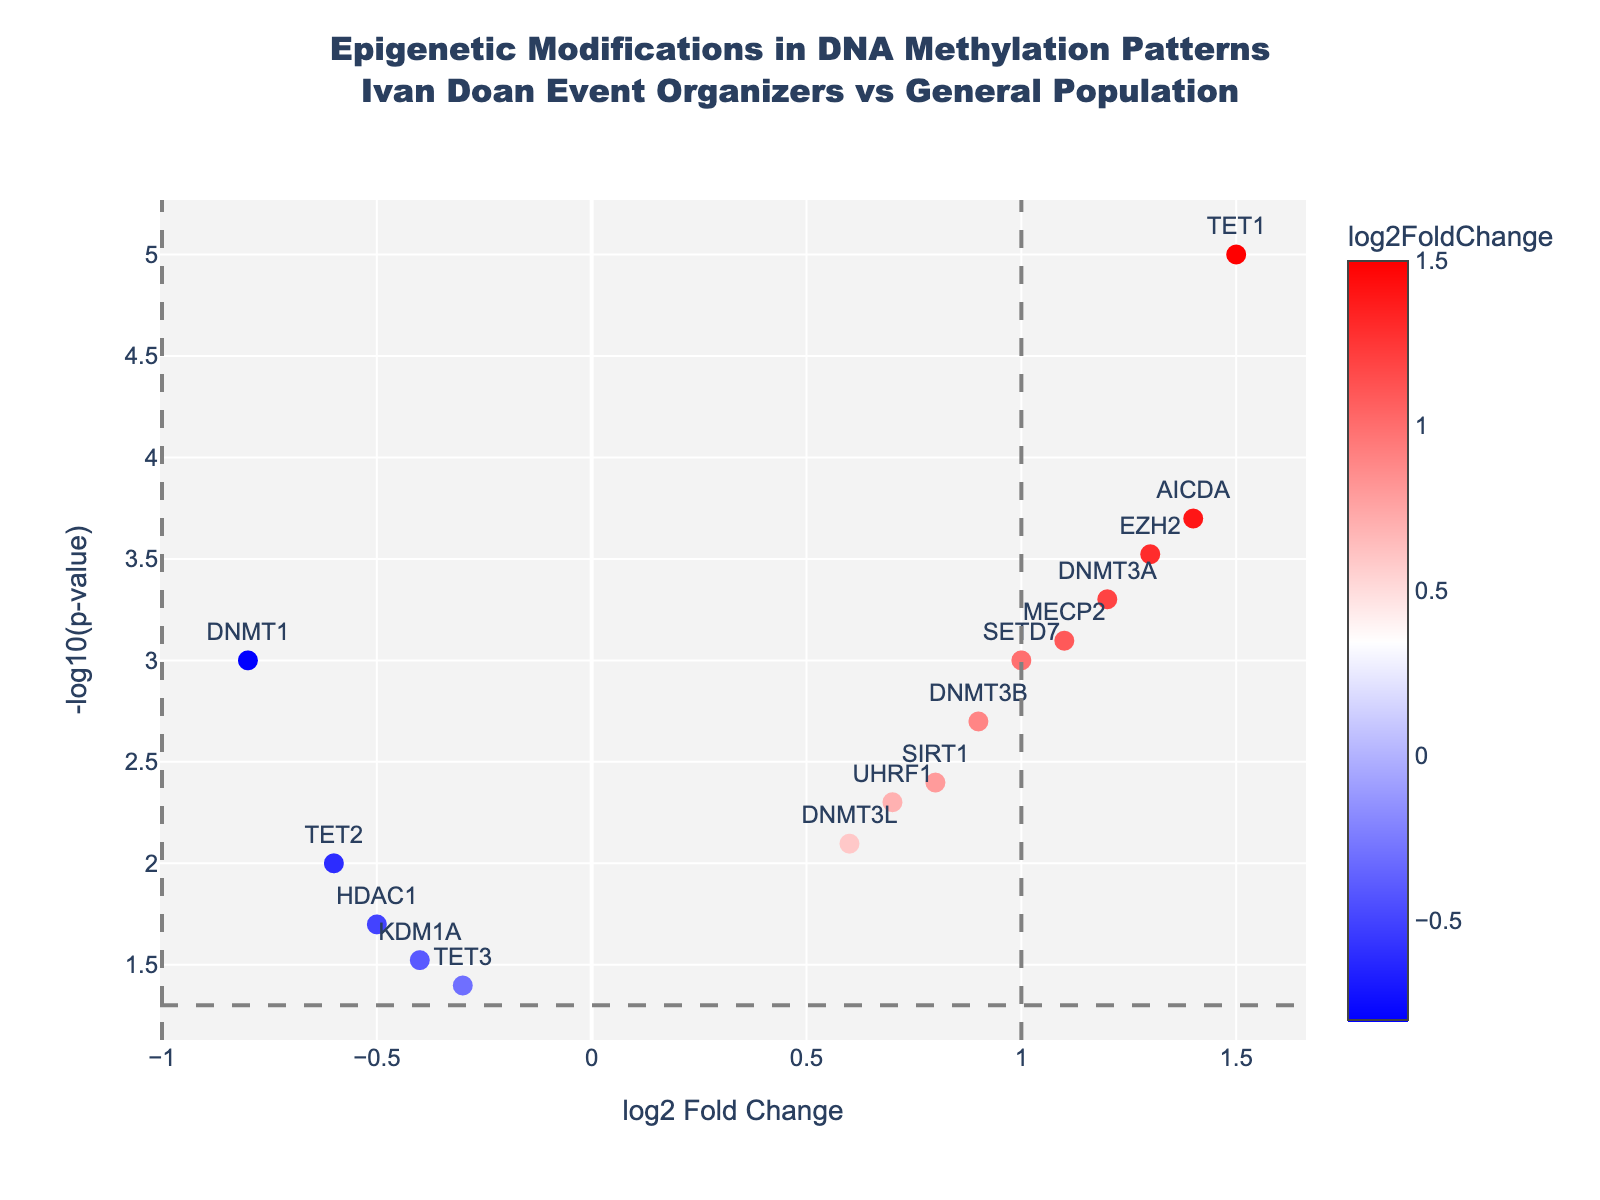what is the title of the plot? The title is prominently displayed at the top of the plot in a larger font size. It reads: “Epigenetic Modifications in DNA Methylation Patterns Ivan Doan Event Organizers vs General Population.”
Answer: Epigenetic Modifications in DNA Methylation Patterns Ivan Doan Event Organizers vs General Population what do the points represent in the plot? Each point in the plot represents a gene, as indicated by the labels next to the points. The genes shown include DNMT1, DNMT3A, and others.
Answer: Genes What is the threshold for the p-value displayed on the plot? The threshold for the p-value can be inferred from the horizontal grey dashed line. The value is -log10(0.05), which translates to a p-value of 0.05.
Answer: 0.05 Which gene has the highest log2 fold change? Identify the point farthest to the right on the x-axis. The gene label next to this point is "TET1," which has the highest log2 fold change.
Answer: TET1 Which genes have log2 fold changes greater than 1? Identify the points to the right of x = 1 and check the gene labels next to these points. The genes are DNMT3A, EZH2, TET1, AICDA, and MECP2.
Answer: DNMT3A, EZH2, TET1, AICDA, and MECP2 What is the log2 fold change and p-value of the MECP2 gene? Hover over the point labeled "MECP2" to view the hover text that shows log2 fold change of 1.1 and p-value of 0.0008.
Answer: log2 fold change: 1.1, p-value: 0.0008 How many genes have a log2 fold change less than -0.5? Count the points to the left of x = -0.5. The genes DNMT1 and TET2 meet this criteria.
Answer: 2 How many genes have a p-value less than 0.01? Identify the points above the horizontal dashed line (threshold at -log10(0.01)). The genes DNMT1, DNMT3A, DNMT3B, TET1, MECP2, EZH2, SIRT1, AICDA, and SETD7 meet this criteria.
Answer: 9 Which gene has the lowest p-value? Identify the point highest on the y-axis, as it indicates the largest -log10(p-value). The gene label next to this point is "TET1," which has the lowest p-value.
Answer: TET1 